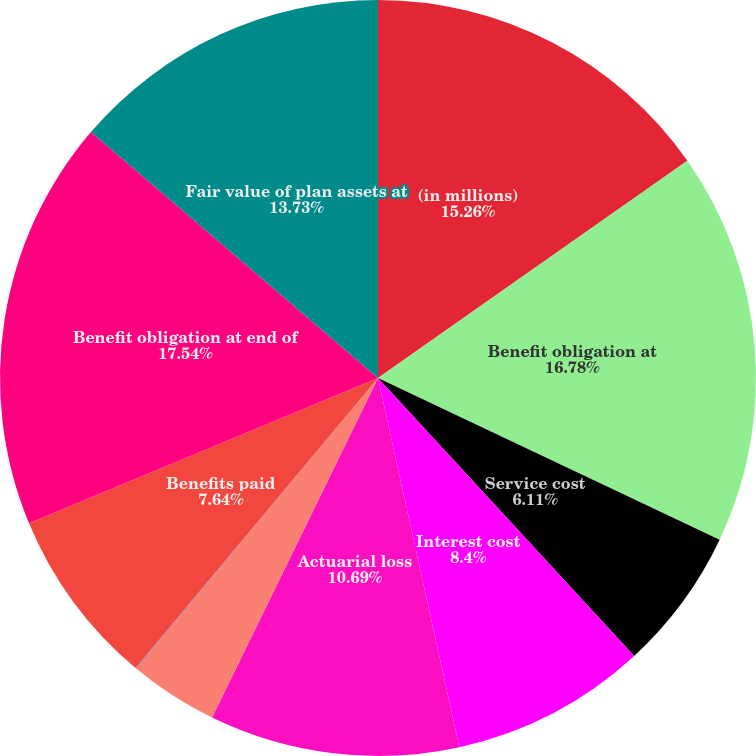<chart> <loc_0><loc_0><loc_500><loc_500><pie_chart><fcel>(in millions)<fcel>Benefit obligation at<fcel>Service cost<fcel>Interest cost<fcel>Actuarial loss<fcel>Plan participants'<fcel>Medicare Part D subsidy<fcel>Benefits paid<fcel>Benefit obligation at end of<fcel>Fair value of plan assets at<nl><fcel>15.26%<fcel>16.78%<fcel>6.11%<fcel>8.4%<fcel>10.69%<fcel>3.83%<fcel>0.02%<fcel>7.64%<fcel>17.55%<fcel>13.73%<nl></chart> 